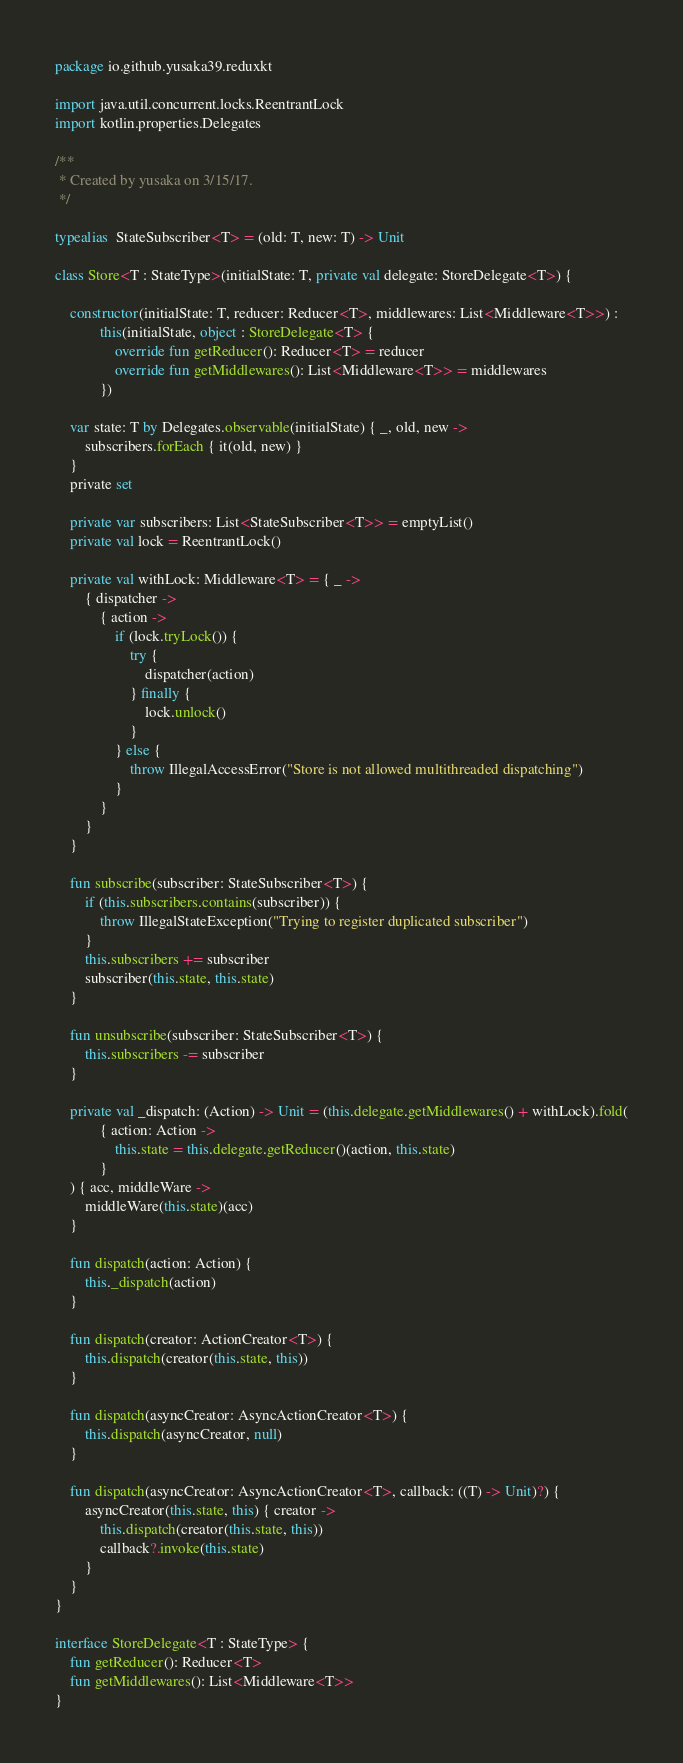Convert code to text. <code><loc_0><loc_0><loc_500><loc_500><_Kotlin_>package io.github.yusaka39.reduxkt

import java.util.concurrent.locks.ReentrantLock
import kotlin.properties.Delegates

/**
 * Created by yusaka on 3/15/17.
 */

typealias  StateSubscriber<T> = (old: T, new: T) -> Unit

class Store<T : StateType>(initialState: T, private val delegate: StoreDelegate<T>) {

    constructor(initialState: T, reducer: Reducer<T>, middlewares: List<Middleware<T>>) :
            this(initialState, object : StoreDelegate<T> {
                override fun getReducer(): Reducer<T> = reducer
                override fun getMiddlewares(): List<Middleware<T>> = middlewares
            })

    var state: T by Delegates.observable(initialState) { _, old, new ->
        subscribers.forEach { it(old, new) }
    }
    private set

    private var subscribers: List<StateSubscriber<T>> = emptyList()
    private val lock = ReentrantLock()

    private val withLock: Middleware<T> = { _ ->
        { dispatcher ->
            { action ->
                if (lock.tryLock()) {
                    try {
                        dispatcher(action)
                    } finally {
                        lock.unlock()
                    }
                } else {
                    throw IllegalAccessError("Store is not allowed multithreaded dispatching")
                }
            }
        }
    }

    fun subscribe(subscriber: StateSubscriber<T>) {
        if (this.subscribers.contains(subscriber)) {
            throw IllegalStateException("Trying to register duplicated subscriber")
        }
        this.subscribers += subscriber
        subscriber(this.state, this.state)
    }

    fun unsubscribe(subscriber: StateSubscriber<T>) {
        this.subscribers -= subscriber
    }

    private val _dispatch: (Action) -> Unit = (this.delegate.getMiddlewares() + withLock).fold(
            { action: Action ->
                this.state = this.delegate.getReducer()(action, this.state)
            }
    ) { acc, middleWare ->
        middleWare(this.state)(acc)
    }

    fun dispatch(action: Action) {
        this._dispatch(action)
    }

    fun dispatch(creator: ActionCreator<T>) {
        this.dispatch(creator(this.state, this))
    }

    fun dispatch(asyncCreator: AsyncActionCreator<T>) {
        this.dispatch(asyncCreator, null)
    }

    fun dispatch(asyncCreator: AsyncActionCreator<T>, callback: ((T) -> Unit)?) {
        asyncCreator(this.state, this) { creator ->
            this.dispatch(creator(this.state, this))
            callback?.invoke(this.state)
        }
    }
}

interface StoreDelegate<T : StateType> {
    fun getReducer(): Reducer<T>
    fun getMiddlewares(): List<Middleware<T>>
}</code> 